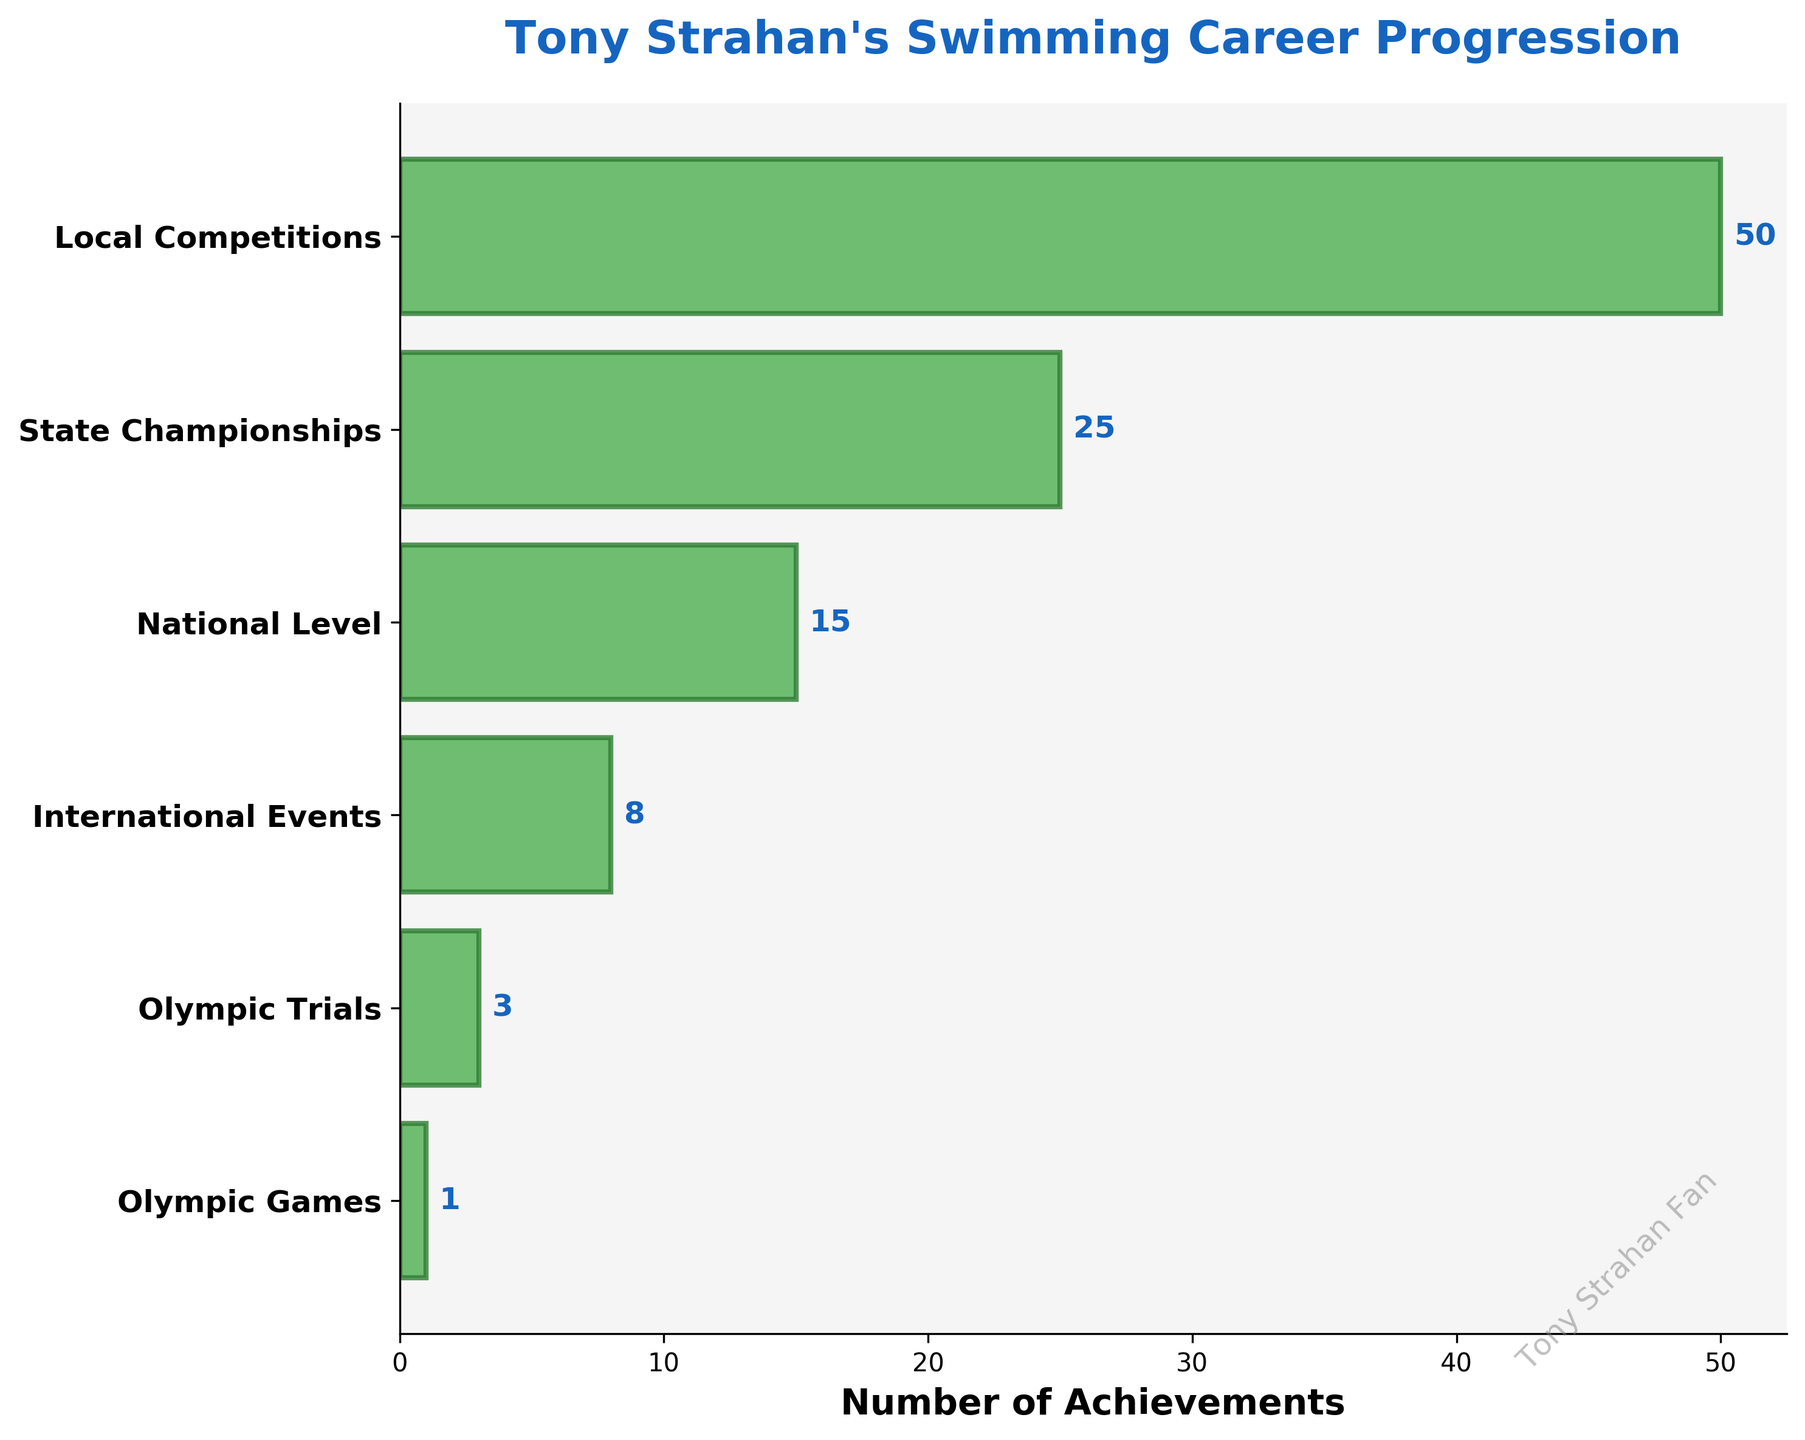What's the title of the figure? The title is usually found at the top of the figure and gives an idea about what the figure represents. In this case, it's written in large, bold font.
Answer: "Tony Strahan's Swimming Career Progression" How many stages are in Tony Strahan's swimming career as shown in the figure? Count the number of distinct stages listed along the y-axis. Here, each stage is labeled clearly on the left side.
Answer: 6 Which stage has the highest number of achievements? The stage with the highest count will be represented by the widest bar.
Answer: Local Competitions (50) Which stage has the fewest achievements? The stage with the smallest count will be represented by the narrowest bar.
Answer: Olympic Games (1) How many more achievements does Tony Strahan have at the National Level compared to the International Events stage? Subtract the count of achievements at the International Events stage from the count at the National Level stage. National Level = 15, International Events = 8.
Answer: 7 (15 - 8) What is the total number of achievements across all stages? Sum the counts of achievements at each stage. 50 + 25 + 15 + 8 + 3 + 1.
Answer: 102 On average, how many achievements does Tony Strahan have per stage? The average is found by dividing the total number of achievements by the number of stages. Total achievements = 102, Number of stages = 6.
Answer: 17 (102 / 6) How many achievements does Tony Strahan have in State Championships and Olympic Trials combined? Add the counts of achievements in these two stages. State Championships = 25, Olympic Trials = 3.
Answer: 28 (25 + 3) Which has a higher number, Queensland Surf Lifesaving Titles or World Surf Lifesaving Championships Medals, and by how much? Compare the counts of these two achievements. State Championships = 25, World Surf Lifesaving Championships Medals = 8.
Answer: Queensland Surf Lifesaving Titles by 17 (25 - 8) What's the difference in the number of achievements between the stages with the highest and the second-highest counts? Subtract the number of achievements in the stage with the second-highest count from the number in the stage with the highest count. Highest = Local Competitions (50), Second-highest = State Championships (25).
Answer: 25 (50 - 25) 